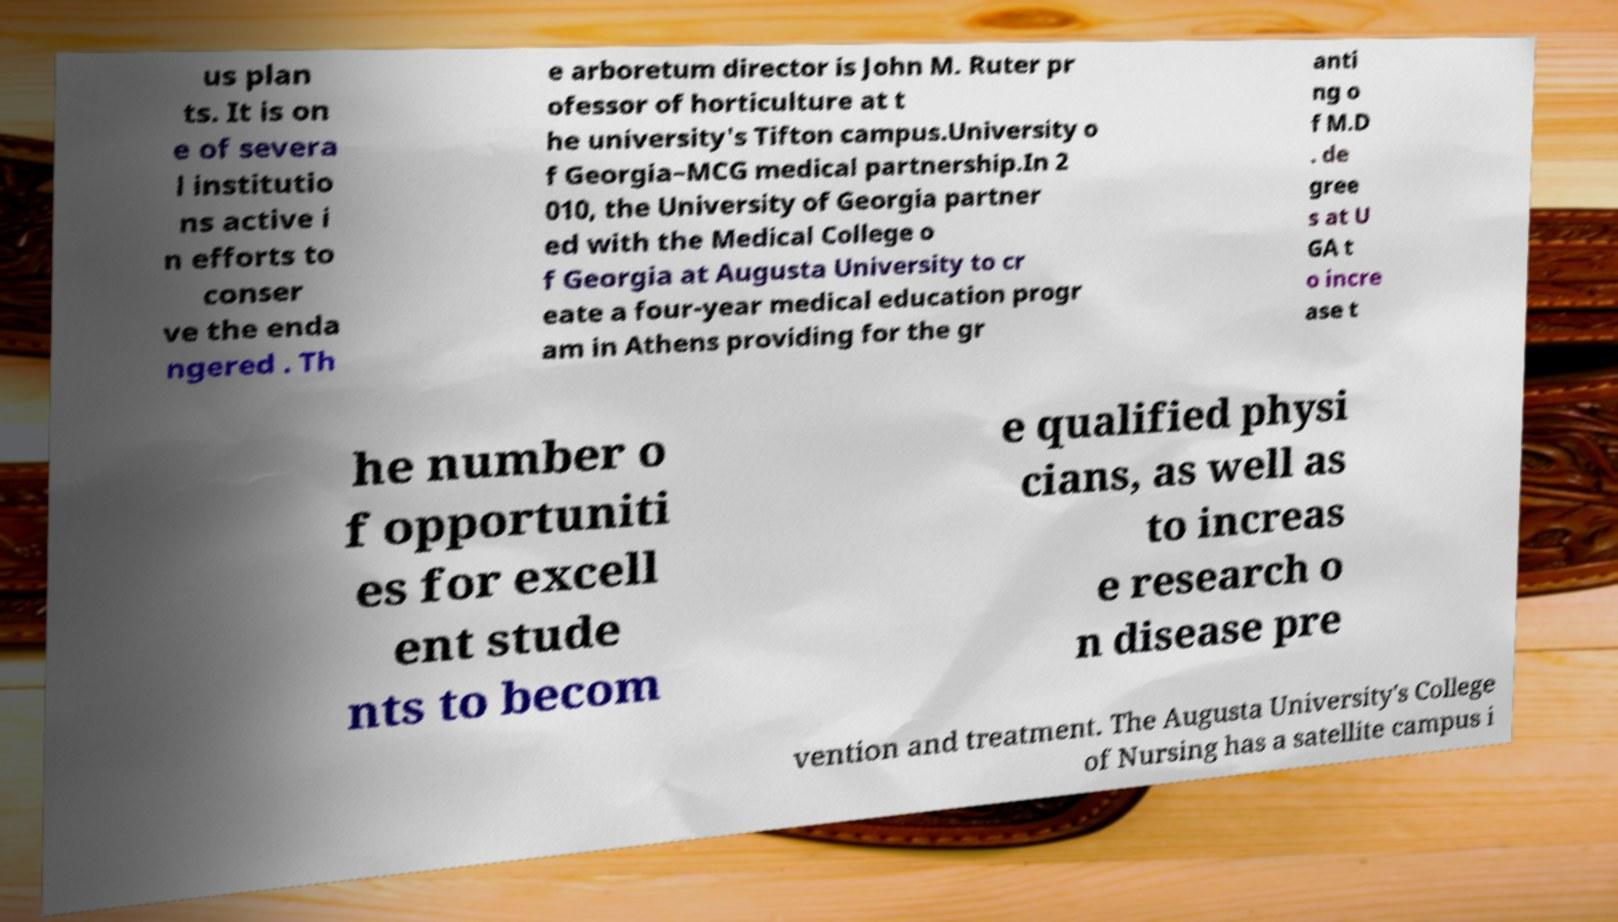Can you accurately transcribe the text from the provided image for me? us plan ts. It is on e of severa l institutio ns active i n efforts to conser ve the enda ngered . Th e arboretum director is John M. Ruter pr ofessor of horticulture at t he university's Tifton campus.University o f Georgia–MCG medical partnership.In 2 010, the University of Georgia partner ed with the Medical College o f Georgia at Augusta University to cr eate a four-year medical education progr am in Athens providing for the gr anti ng o f M.D . de gree s at U GA t o incre ase t he number o f opportuniti es for excell ent stude nts to becom e qualified physi cians, as well as to increas e research o n disease pre vention and treatment. The Augusta University's College of Nursing has a satellite campus i 